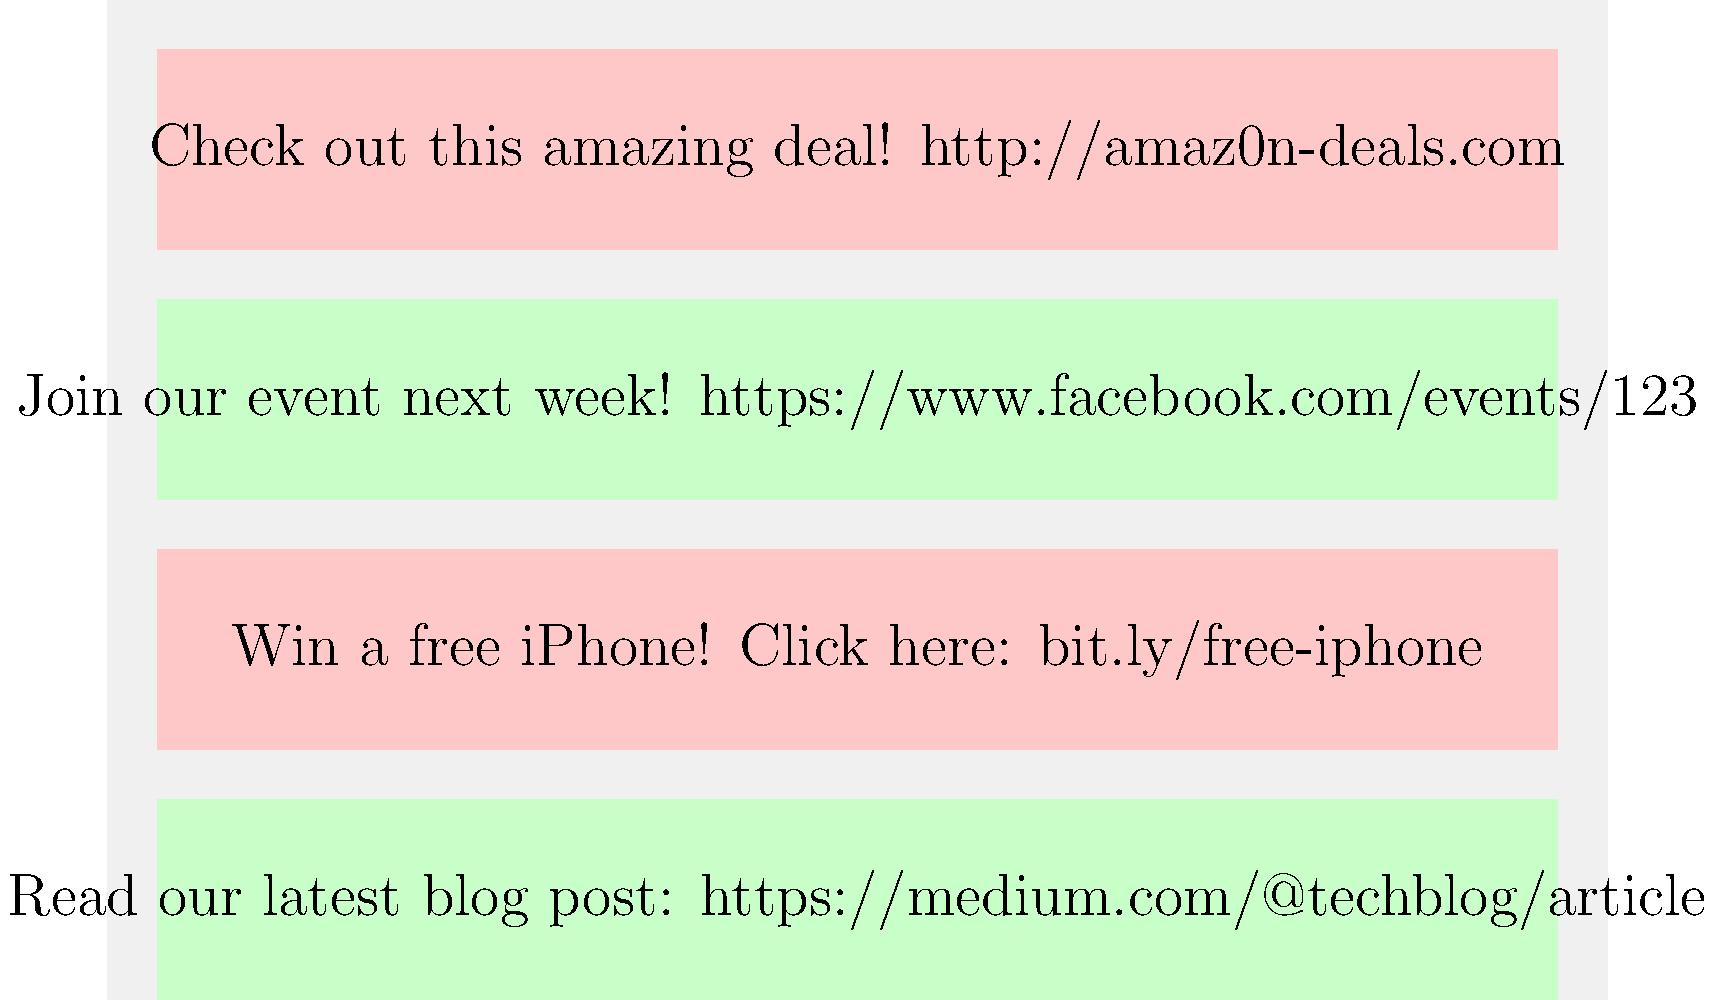Based on the social media posts shown in the image, which of the following statements is correct regarding safe and unsafe URLs?

A) All URLs in the posts are safe to click
B) Only URLs from well-known domains like Facebook and Medium are safe
C) Short URLs like bit.ly links are always safe
D) URLs with slight misspellings or unfamiliar domains should be treated with caution To recognize and avoid malicious links on social media platforms, follow these steps:

1. Analyze the domain names:
   - Known, reputable domains (e.g., facebook.com, medium.com) are generally safer.
   - Suspicious domains (e.g., amaz0n-deals.com) with slight misspellings or unfamiliar names should be treated cautiously.

2. Check for HTTPS:
   - Secure links typically start with "https://" (though this alone doesn't guarantee safety).

3. Be wary of shortened URLs:
   - Links like "bit.ly" can hide the actual destination and should be approached carefully.

4. Consider the context:
   - Posts promising free items or amazing deals often lead to scams or malicious sites.

5. Examine the post content:
   - Legitimate companies rarely ask you to click suspicious links for prizes or deals.

In the image:
- The first post (red) has a suspicious URL (amaz0n-deals.com) mimicking Amazon.
- The second post (green) links to a legitimate Facebook event page.
- The third post (red) uses a shortened URL (bit.ly) and promises a free iPhone, which is suspicious.
- The fourth post (green) links to a legitimate Medium blog post.

Therefore, the correct approach is to be cautious of URLs with slight misspellings, unfamiliar domains, or those promising unrealistic offers, while links from well-known platforms are generally safer (but not guaranteed to be safe).
Answer: D) URLs with slight misspellings or unfamiliar domains should be treated with caution 